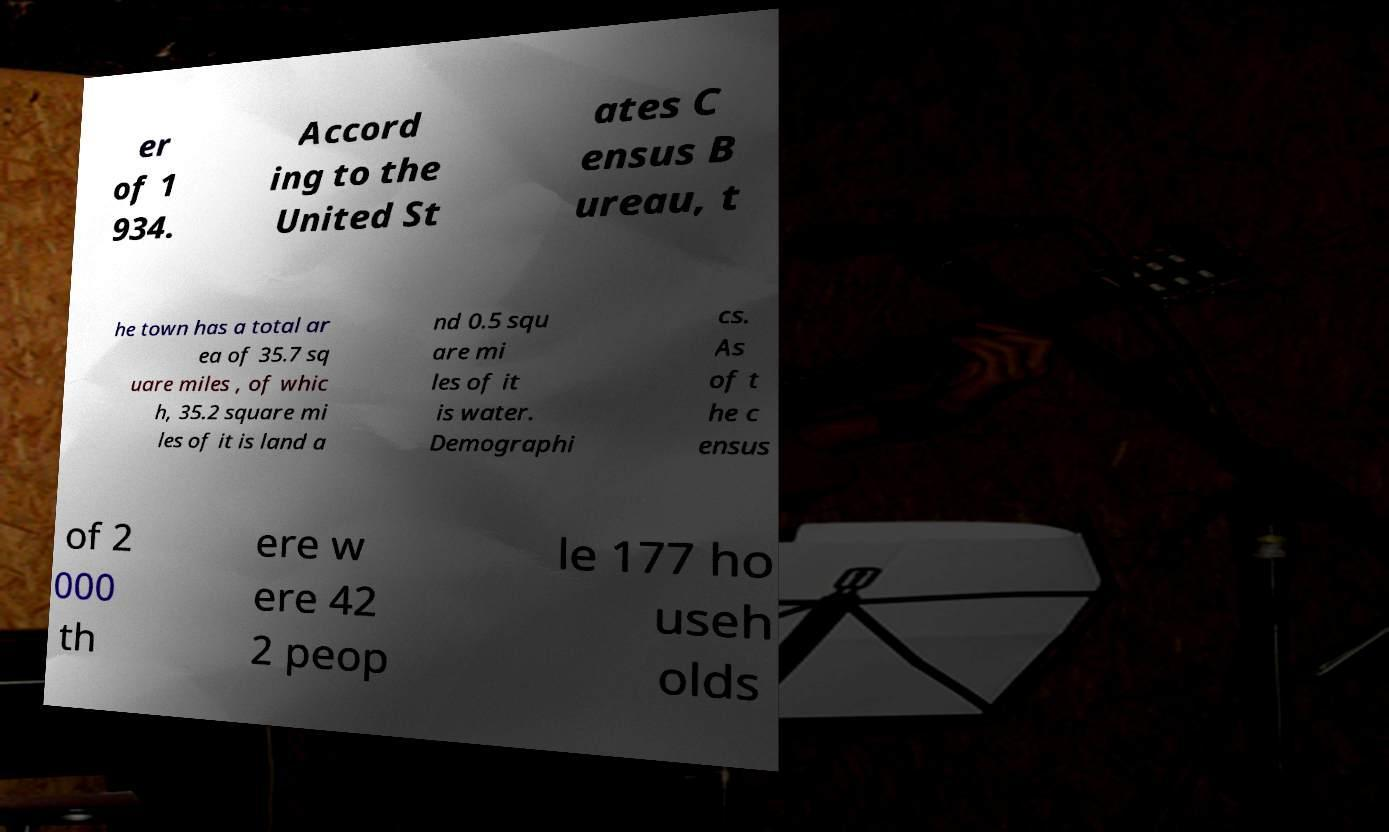Please read and relay the text visible in this image. What does it say? er of 1 934. Accord ing to the United St ates C ensus B ureau, t he town has a total ar ea of 35.7 sq uare miles , of whic h, 35.2 square mi les of it is land a nd 0.5 squ are mi les of it is water. Demographi cs. As of t he c ensus of 2 000 th ere w ere 42 2 peop le 177 ho useh olds 